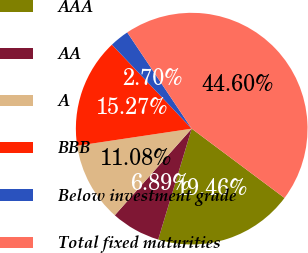Convert chart to OTSL. <chart><loc_0><loc_0><loc_500><loc_500><pie_chart><fcel>AAA<fcel>AA<fcel>A<fcel>BBB<fcel>Below investment grade<fcel>Total fixed maturities<nl><fcel>19.46%<fcel>6.89%<fcel>11.08%<fcel>15.27%<fcel>2.7%<fcel>44.6%<nl></chart> 